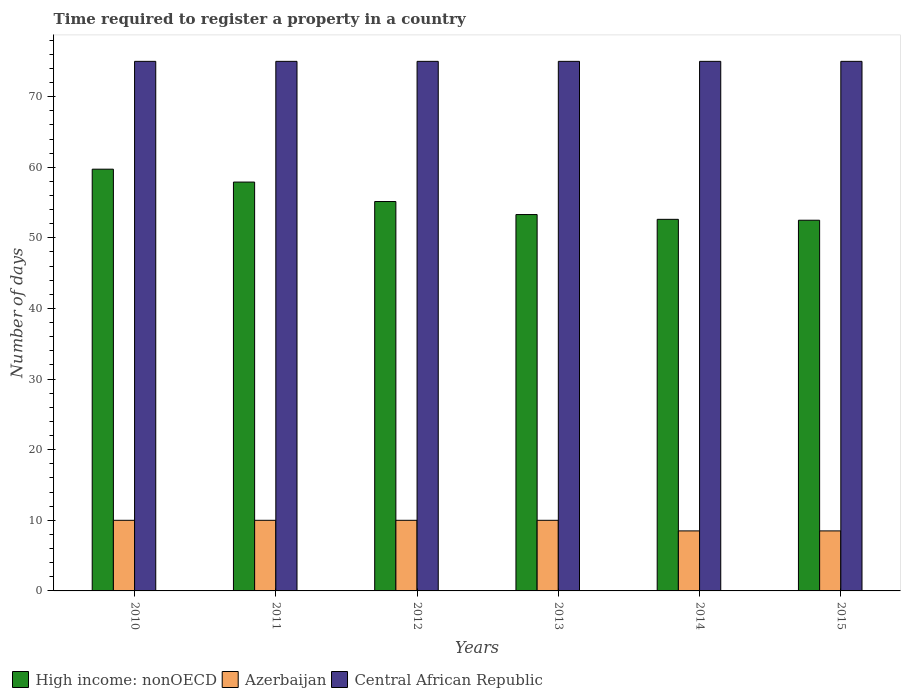How many different coloured bars are there?
Offer a terse response. 3. Are the number of bars per tick equal to the number of legend labels?
Provide a short and direct response. Yes. Are the number of bars on each tick of the X-axis equal?
Provide a succinct answer. Yes. What is the label of the 4th group of bars from the left?
Your response must be concise. 2013. In how many cases, is the number of bars for a given year not equal to the number of legend labels?
Your answer should be very brief. 0. Across all years, what is the minimum number of days required to register a property in High income: nonOECD?
Ensure brevity in your answer.  52.5. In which year was the number of days required to register a property in High income: nonOECD maximum?
Make the answer very short. 2010. In which year was the number of days required to register a property in High income: nonOECD minimum?
Make the answer very short. 2015. What is the difference between the number of days required to register a property in Azerbaijan in 2010 and the number of days required to register a property in High income: nonOECD in 2013?
Offer a terse response. -43.3. What is the average number of days required to register a property in Central African Republic per year?
Give a very brief answer. 75. In the year 2012, what is the difference between the number of days required to register a property in High income: nonOECD and number of days required to register a property in Central African Republic?
Provide a short and direct response. -19.85. Is the difference between the number of days required to register a property in High income: nonOECD in 2010 and 2014 greater than the difference between the number of days required to register a property in Central African Republic in 2010 and 2014?
Offer a terse response. Yes. Is the sum of the number of days required to register a property in Central African Republic in 2012 and 2013 greater than the maximum number of days required to register a property in High income: nonOECD across all years?
Your response must be concise. Yes. What does the 2nd bar from the left in 2012 represents?
Your answer should be very brief. Azerbaijan. What does the 2nd bar from the right in 2010 represents?
Provide a short and direct response. Azerbaijan. Is it the case that in every year, the sum of the number of days required to register a property in Azerbaijan and number of days required to register a property in Central African Republic is greater than the number of days required to register a property in High income: nonOECD?
Provide a succinct answer. Yes. How many bars are there?
Offer a terse response. 18. Are the values on the major ticks of Y-axis written in scientific E-notation?
Offer a terse response. No. Does the graph contain grids?
Provide a succinct answer. No. Where does the legend appear in the graph?
Give a very brief answer. Bottom left. How many legend labels are there?
Ensure brevity in your answer.  3. What is the title of the graph?
Provide a short and direct response. Time required to register a property in a country. What is the label or title of the Y-axis?
Keep it short and to the point. Number of days. What is the Number of days in High income: nonOECD in 2010?
Your answer should be very brief. 59.73. What is the Number of days in Azerbaijan in 2010?
Provide a short and direct response. 10. What is the Number of days in High income: nonOECD in 2011?
Keep it short and to the point. 57.9. What is the Number of days in Azerbaijan in 2011?
Make the answer very short. 10. What is the Number of days in High income: nonOECD in 2012?
Provide a short and direct response. 55.15. What is the Number of days in Azerbaijan in 2012?
Make the answer very short. 10. What is the Number of days of High income: nonOECD in 2013?
Offer a terse response. 53.3. What is the Number of days of High income: nonOECD in 2014?
Make the answer very short. 52.62. What is the Number of days in Azerbaijan in 2014?
Offer a terse response. 8.5. What is the Number of days in High income: nonOECD in 2015?
Provide a succinct answer. 52.5. What is the Number of days in Azerbaijan in 2015?
Your answer should be compact. 8.5. Across all years, what is the maximum Number of days in High income: nonOECD?
Offer a very short reply. 59.73. Across all years, what is the minimum Number of days of High income: nonOECD?
Your answer should be compact. 52.5. Across all years, what is the minimum Number of days in Azerbaijan?
Offer a very short reply. 8.5. What is the total Number of days in High income: nonOECD in the graph?
Ensure brevity in your answer.  331.21. What is the total Number of days in Azerbaijan in the graph?
Your response must be concise. 57. What is the total Number of days of Central African Republic in the graph?
Provide a short and direct response. 450. What is the difference between the Number of days in High income: nonOECD in 2010 and that in 2011?
Provide a succinct answer. 1.83. What is the difference between the Number of days in Central African Republic in 2010 and that in 2011?
Keep it short and to the point. 0. What is the difference between the Number of days in High income: nonOECD in 2010 and that in 2012?
Offer a terse response. 4.58. What is the difference between the Number of days in Azerbaijan in 2010 and that in 2012?
Give a very brief answer. 0. What is the difference between the Number of days in High income: nonOECD in 2010 and that in 2013?
Make the answer very short. 6.43. What is the difference between the Number of days in Azerbaijan in 2010 and that in 2013?
Offer a very short reply. 0. What is the difference between the Number of days of Central African Republic in 2010 and that in 2013?
Your answer should be compact. 0. What is the difference between the Number of days in High income: nonOECD in 2010 and that in 2014?
Offer a very short reply. 7.1. What is the difference between the Number of days of Azerbaijan in 2010 and that in 2014?
Provide a succinct answer. 1.5. What is the difference between the Number of days in Central African Republic in 2010 and that in 2014?
Provide a short and direct response. 0. What is the difference between the Number of days of High income: nonOECD in 2010 and that in 2015?
Give a very brief answer. 7.23. What is the difference between the Number of days of Azerbaijan in 2010 and that in 2015?
Offer a terse response. 1.5. What is the difference between the Number of days in High income: nonOECD in 2011 and that in 2012?
Offer a terse response. 2.76. What is the difference between the Number of days in Central African Republic in 2011 and that in 2012?
Your answer should be compact. 0. What is the difference between the Number of days of High income: nonOECD in 2011 and that in 2013?
Give a very brief answer. 4.6. What is the difference between the Number of days in Azerbaijan in 2011 and that in 2013?
Provide a short and direct response. 0. What is the difference between the Number of days in Central African Republic in 2011 and that in 2013?
Keep it short and to the point. 0. What is the difference between the Number of days in High income: nonOECD in 2011 and that in 2014?
Provide a succinct answer. 5.28. What is the difference between the Number of days of High income: nonOECD in 2011 and that in 2015?
Your answer should be very brief. 5.4. What is the difference between the Number of days in Central African Republic in 2011 and that in 2015?
Offer a very short reply. 0. What is the difference between the Number of days of High income: nonOECD in 2012 and that in 2013?
Keep it short and to the point. 1.84. What is the difference between the Number of days of Azerbaijan in 2012 and that in 2013?
Make the answer very short. 0. What is the difference between the Number of days in High income: nonOECD in 2012 and that in 2014?
Provide a succinct answer. 2.52. What is the difference between the Number of days in Azerbaijan in 2012 and that in 2014?
Make the answer very short. 1.5. What is the difference between the Number of days of High income: nonOECD in 2012 and that in 2015?
Give a very brief answer. 2.65. What is the difference between the Number of days in Central African Republic in 2012 and that in 2015?
Your response must be concise. 0. What is the difference between the Number of days in High income: nonOECD in 2013 and that in 2014?
Ensure brevity in your answer.  0.68. What is the difference between the Number of days of Azerbaijan in 2013 and that in 2014?
Your answer should be compact. 1.5. What is the difference between the Number of days in Central African Republic in 2013 and that in 2014?
Offer a very short reply. 0. What is the difference between the Number of days in High income: nonOECD in 2013 and that in 2015?
Give a very brief answer. 0.8. What is the difference between the Number of days in Azerbaijan in 2013 and that in 2015?
Provide a succinct answer. 1.5. What is the difference between the Number of days of High income: nonOECD in 2014 and that in 2015?
Your answer should be very brief. 0.12. What is the difference between the Number of days of High income: nonOECD in 2010 and the Number of days of Azerbaijan in 2011?
Your answer should be compact. 49.73. What is the difference between the Number of days of High income: nonOECD in 2010 and the Number of days of Central African Republic in 2011?
Give a very brief answer. -15.27. What is the difference between the Number of days of Azerbaijan in 2010 and the Number of days of Central African Republic in 2011?
Your response must be concise. -65. What is the difference between the Number of days of High income: nonOECD in 2010 and the Number of days of Azerbaijan in 2012?
Offer a very short reply. 49.73. What is the difference between the Number of days of High income: nonOECD in 2010 and the Number of days of Central African Republic in 2012?
Your answer should be compact. -15.27. What is the difference between the Number of days in Azerbaijan in 2010 and the Number of days in Central African Republic in 2012?
Provide a short and direct response. -65. What is the difference between the Number of days of High income: nonOECD in 2010 and the Number of days of Azerbaijan in 2013?
Provide a short and direct response. 49.73. What is the difference between the Number of days in High income: nonOECD in 2010 and the Number of days in Central African Republic in 2013?
Your answer should be very brief. -15.27. What is the difference between the Number of days of Azerbaijan in 2010 and the Number of days of Central African Republic in 2013?
Your answer should be compact. -65. What is the difference between the Number of days of High income: nonOECD in 2010 and the Number of days of Azerbaijan in 2014?
Give a very brief answer. 51.23. What is the difference between the Number of days in High income: nonOECD in 2010 and the Number of days in Central African Republic in 2014?
Your answer should be compact. -15.27. What is the difference between the Number of days of Azerbaijan in 2010 and the Number of days of Central African Republic in 2014?
Your response must be concise. -65. What is the difference between the Number of days of High income: nonOECD in 2010 and the Number of days of Azerbaijan in 2015?
Your answer should be compact. 51.23. What is the difference between the Number of days in High income: nonOECD in 2010 and the Number of days in Central African Republic in 2015?
Offer a very short reply. -15.27. What is the difference between the Number of days of Azerbaijan in 2010 and the Number of days of Central African Republic in 2015?
Your response must be concise. -65. What is the difference between the Number of days in High income: nonOECD in 2011 and the Number of days in Azerbaijan in 2012?
Give a very brief answer. 47.9. What is the difference between the Number of days of High income: nonOECD in 2011 and the Number of days of Central African Republic in 2012?
Make the answer very short. -17.1. What is the difference between the Number of days in Azerbaijan in 2011 and the Number of days in Central African Republic in 2012?
Keep it short and to the point. -65. What is the difference between the Number of days of High income: nonOECD in 2011 and the Number of days of Azerbaijan in 2013?
Your response must be concise. 47.9. What is the difference between the Number of days in High income: nonOECD in 2011 and the Number of days in Central African Republic in 2013?
Your answer should be very brief. -17.1. What is the difference between the Number of days of Azerbaijan in 2011 and the Number of days of Central African Republic in 2013?
Your response must be concise. -65. What is the difference between the Number of days in High income: nonOECD in 2011 and the Number of days in Azerbaijan in 2014?
Offer a very short reply. 49.4. What is the difference between the Number of days in High income: nonOECD in 2011 and the Number of days in Central African Republic in 2014?
Keep it short and to the point. -17.1. What is the difference between the Number of days of Azerbaijan in 2011 and the Number of days of Central African Republic in 2014?
Your response must be concise. -65. What is the difference between the Number of days in High income: nonOECD in 2011 and the Number of days in Azerbaijan in 2015?
Your answer should be very brief. 49.4. What is the difference between the Number of days in High income: nonOECD in 2011 and the Number of days in Central African Republic in 2015?
Your answer should be very brief. -17.1. What is the difference between the Number of days of Azerbaijan in 2011 and the Number of days of Central African Republic in 2015?
Offer a very short reply. -65. What is the difference between the Number of days of High income: nonOECD in 2012 and the Number of days of Azerbaijan in 2013?
Make the answer very short. 45.15. What is the difference between the Number of days in High income: nonOECD in 2012 and the Number of days in Central African Republic in 2013?
Make the answer very short. -19.85. What is the difference between the Number of days in Azerbaijan in 2012 and the Number of days in Central African Republic in 2013?
Your response must be concise. -65. What is the difference between the Number of days in High income: nonOECD in 2012 and the Number of days in Azerbaijan in 2014?
Offer a very short reply. 46.65. What is the difference between the Number of days of High income: nonOECD in 2012 and the Number of days of Central African Republic in 2014?
Offer a very short reply. -19.85. What is the difference between the Number of days in Azerbaijan in 2012 and the Number of days in Central African Republic in 2014?
Offer a very short reply. -65. What is the difference between the Number of days of High income: nonOECD in 2012 and the Number of days of Azerbaijan in 2015?
Offer a very short reply. 46.65. What is the difference between the Number of days of High income: nonOECD in 2012 and the Number of days of Central African Republic in 2015?
Offer a very short reply. -19.85. What is the difference between the Number of days in Azerbaijan in 2012 and the Number of days in Central African Republic in 2015?
Ensure brevity in your answer.  -65. What is the difference between the Number of days of High income: nonOECD in 2013 and the Number of days of Azerbaijan in 2014?
Your answer should be compact. 44.8. What is the difference between the Number of days of High income: nonOECD in 2013 and the Number of days of Central African Republic in 2014?
Ensure brevity in your answer.  -21.7. What is the difference between the Number of days of Azerbaijan in 2013 and the Number of days of Central African Republic in 2014?
Give a very brief answer. -65. What is the difference between the Number of days in High income: nonOECD in 2013 and the Number of days in Azerbaijan in 2015?
Your response must be concise. 44.8. What is the difference between the Number of days in High income: nonOECD in 2013 and the Number of days in Central African Republic in 2015?
Give a very brief answer. -21.7. What is the difference between the Number of days in Azerbaijan in 2013 and the Number of days in Central African Republic in 2015?
Your answer should be very brief. -65. What is the difference between the Number of days of High income: nonOECD in 2014 and the Number of days of Azerbaijan in 2015?
Provide a succinct answer. 44.12. What is the difference between the Number of days of High income: nonOECD in 2014 and the Number of days of Central African Republic in 2015?
Offer a very short reply. -22.38. What is the difference between the Number of days in Azerbaijan in 2014 and the Number of days in Central African Republic in 2015?
Provide a succinct answer. -66.5. What is the average Number of days in High income: nonOECD per year?
Your answer should be compact. 55.2. In the year 2010, what is the difference between the Number of days in High income: nonOECD and Number of days in Azerbaijan?
Ensure brevity in your answer.  49.73. In the year 2010, what is the difference between the Number of days of High income: nonOECD and Number of days of Central African Republic?
Keep it short and to the point. -15.27. In the year 2010, what is the difference between the Number of days of Azerbaijan and Number of days of Central African Republic?
Your response must be concise. -65. In the year 2011, what is the difference between the Number of days in High income: nonOECD and Number of days in Azerbaijan?
Your answer should be compact. 47.9. In the year 2011, what is the difference between the Number of days of High income: nonOECD and Number of days of Central African Republic?
Provide a short and direct response. -17.1. In the year 2011, what is the difference between the Number of days in Azerbaijan and Number of days in Central African Republic?
Provide a succinct answer. -65. In the year 2012, what is the difference between the Number of days of High income: nonOECD and Number of days of Azerbaijan?
Provide a short and direct response. 45.15. In the year 2012, what is the difference between the Number of days of High income: nonOECD and Number of days of Central African Republic?
Ensure brevity in your answer.  -19.85. In the year 2012, what is the difference between the Number of days in Azerbaijan and Number of days in Central African Republic?
Your answer should be compact. -65. In the year 2013, what is the difference between the Number of days of High income: nonOECD and Number of days of Azerbaijan?
Your answer should be very brief. 43.3. In the year 2013, what is the difference between the Number of days in High income: nonOECD and Number of days in Central African Republic?
Provide a succinct answer. -21.7. In the year 2013, what is the difference between the Number of days of Azerbaijan and Number of days of Central African Republic?
Offer a very short reply. -65. In the year 2014, what is the difference between the Number of days of High income: nonOECD and Number of days of Azerbaijan?
Ensure brevity in your answer.  44.12. In the year 2014, what is the difference between the Number of days of High income: nonOECD and Number of days of Central African Republic?
Keep it short and to the point. -22.38. In the year 2014, what is the difference between the Number of days of Azerbaijan and Number of days of Central African Republic?
Your response must be concise. -66.5. In the year 2015, what is the difference between the Number of days in High income: nonOECD and Number of days in Central African Republic?
Your answer should be very brief. -22.5. In the year 2015, what is the difference between the Number of days in Azerbaijan and Number of days in Central African Republic?
Make the answer very short. -66.5. What is the ratio of the Number of days of High income: nonOECD in 2010 to that in 2011?
Give a very brief answer. 1.03. What is the ratio of the Number of days in Azerbaijan in 2010 to that in 2011?
Make the answer very short. 1. What is the ratio of the Number of days of Central African Republic in 2010 to that in 2011?
Offer a very short reply. 1. What is the ratio of the Number of days of High income: nonOECD in 2010 to that in 2012?
Make the answer very short. 1.08. What is the ratio of the Number of days of Azerbaijan in 2010 to that in 2012?
Your answer should be compact. 1. What is the ratio of the Number of days in Central African Republic in 2010 to that in 2012?
Provide a short and direct response. 1. What is the ratio of the Number of days in High income: nonOECD in 2010 to that in 2013?
Make the answer very short. 1.12. What is the ratio of the Number of days of High income: nonOECD in 2010 to that in 2014?
Offer a very short reply. 1.14. What is the ratio of the Number of days in Azerbaijan in 2010 to that in 2014?
Keep it short and to the point. 1.18. What is the ratio of the Number of days of High income: nonOECD in 2010 to that in 2015?
Your answer should be very brief. 1.14. What is the ratio of the Number of days in Azerbaijan in 2010 to that in 2015?
Ensure brevity in your answer.  1.18. What is the ratio of the Number of days in Central African Republic in 2010 to that in 2015?
Make the answer very short. 1. What is the ratio of the Number of days of High income: nonOECD in 2011 to that in 2012?
Keep it short and to the point. 1.05. What is the ratio of the Number of days of Azerbaijan in 2011 to that in 2012?
Your answer should be compact. 1. What is the ratio of the Number of days of Central African Republic in 2011 to that in 2012?
Offer a very short reply. 1. What is the ratio of the Number of days of High income: nonOECD in 2011 to that in 2013?
Your answer should be very brief. 1.09. What is the ratio of the Number of days in Central African Republic in 2011 to that in 2013?
Your answer should be very brief. 1. What is the ratio of the Number of days in High income: nonOECD in 2011 to that in 2014?
Ensure brevity in your answer.  1.1. What is the ratio of the Number of days of Azerbaijan in 2011 to that in 2014?
Offer a terse response. 1.18. What is the ratio of the Number of days of Central African Republic in 2011 to that in 2014?
Make the answer very short. 1. What is the ratio of the Number of days of High income: nonOECD in 2011 to that in 2015?
Your answer should be compact. 1.1. What is the ratio of the Number of days of Azerbaijan in 2011 to that in 2015?
Your answer should be compact. 1.18. What is the ratio of the Number of days in High income: nonOECD in 2012 to that in 2013?
Your response must be concise. 1.03. What is the ratio of the Number of days in Central African Republic in 2012 to that in 2013?
Keep it short and to the point. 1. What is the ratio of the Number of days in High income: nonOECD in 2012 to that in 2014?
Your answer should be compact. 1.05. What is the ratio of the Number of days of Azerbaijan in 2012 to that in 2014?
Keep it short and to the point. 1.18. What is the ratio of the Number of days in High income: nonOECD in 2012 to that in 2015?
Provide a short and direct response. 1.05. What is the ratio of the Number of days in Azerbaijan in 2012 to that in 2015?
Give a very brief answer. 1.18. What is the ratio of the Number of days of Central African Republic in 2012 to that in 2015?
Keep it short and to the point. 1. What is the ratio of the Number of days in High income: nonOECD in 2013 to that in 2014?
Make the answer very short. 1.01. What is the ratio of the Number of days in Azerbaijan in 2013 to that in 2014?
Keep it short and to the point. 1.18. What is the ratio of the Number of days of Central African Republic in 2013 to that in 2014?
Offer a very short reply. 1. What is the ratio of the Number of days of High income: nonOECD in 2013 to that in 2015?
Offer a terse response. 1.02. What is the ratio of the Number of days in Azerbaijan in 2013 to that in 2015?
Your answer should be very brief. 1.18. What is the ratio of the Number of days of Central African Republic in 2013 to that in 2015?
Provide a short and direct response. 1. What is the ratio of the Number of days in Central African Republic in 2014 to that in 2015?
Offer a terse response. 1. What is the difference between the highest and the second highest Number of days in High income: nonOECD?
Make the answer very short. 1.83. What is the difference between the highest and the second highest Number of days in Azerbaijan?
Your answer should be very brief. 0. What is the difference between the highest and the lowest Number of days in High income: nonOECD?
Your response must be concise. 7.23. 